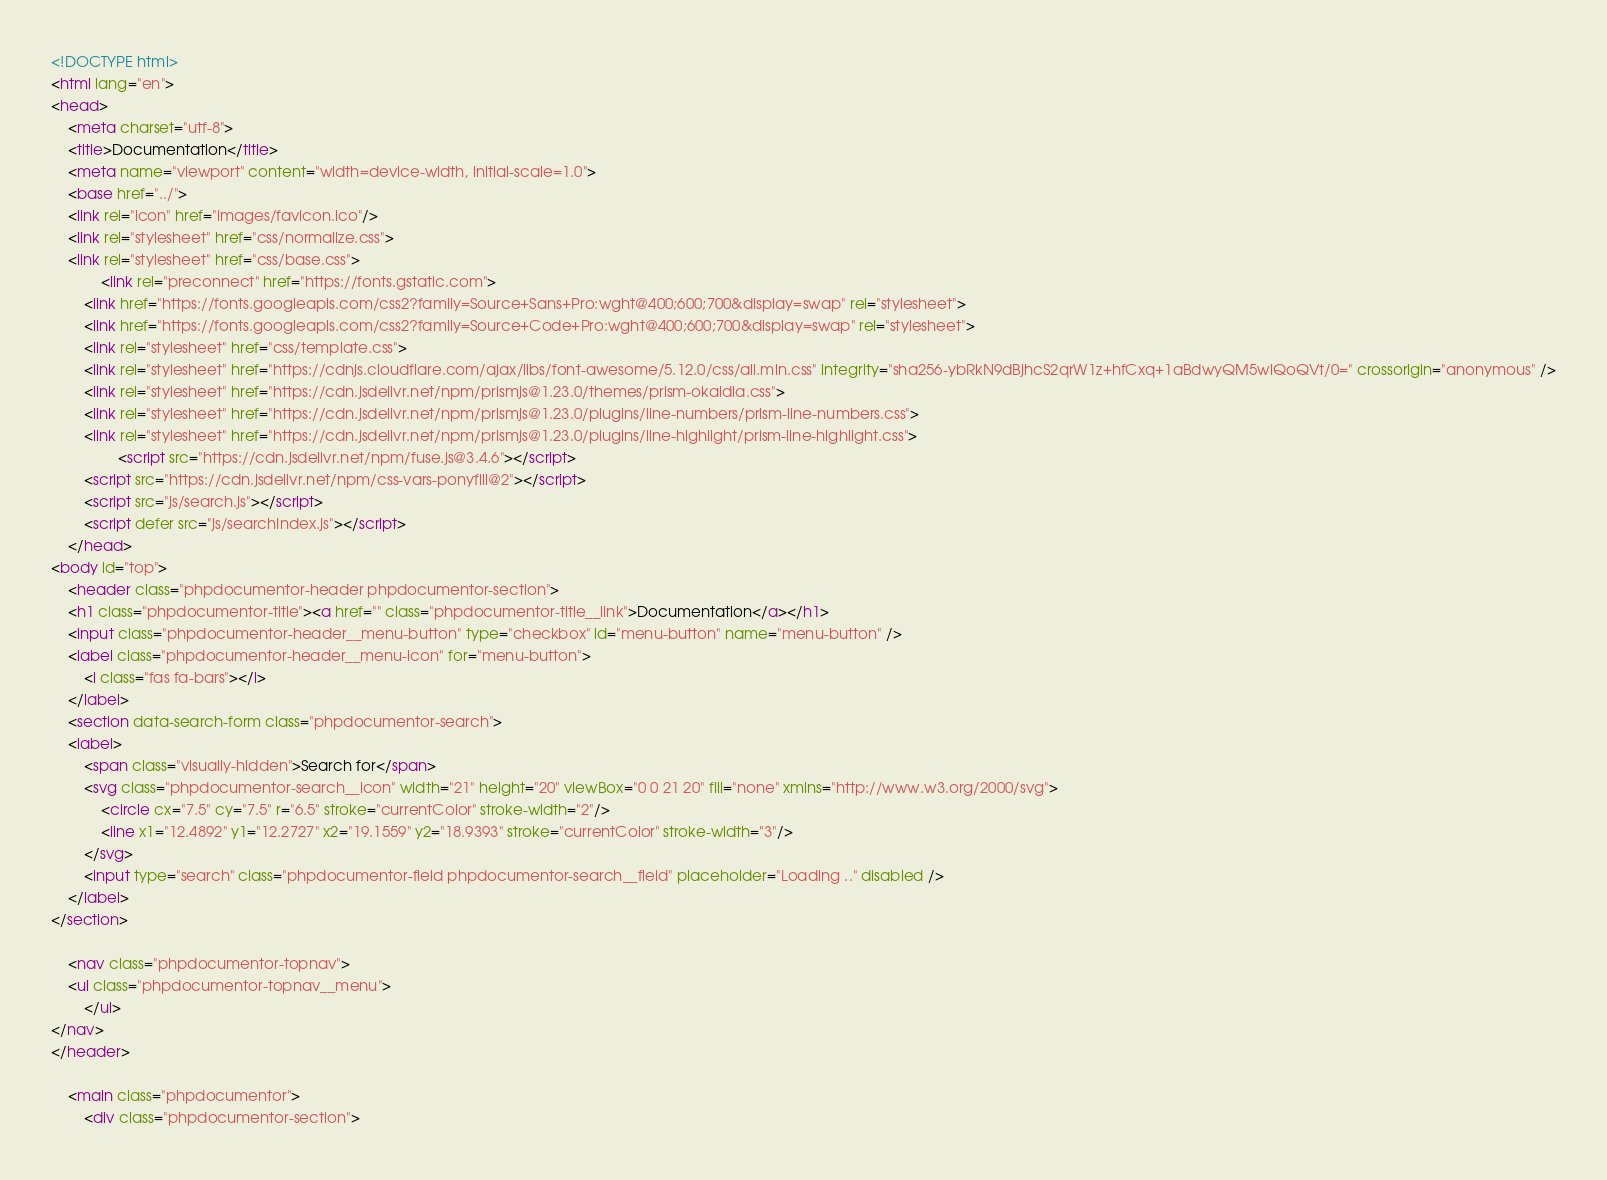<code> <loc_0><loc_0><loc_500><loc_500><_HTML_><!DOCTYPE html>
<html lang="en">
<head>
    <meta charset="utf-8">
    <title>Documentation</title>
    <meta name="viewport" content="width=device-width, initial-scale=1.0">
    <base href="../">
    <link rel="icon" href="images/favicon.ico"/>
    <link rel="stylesheet" href="css/normalize.css">
    <link rel="stylesheet" href="css/base.css">
            <link rel="preconnect" href="https://fonts.gstatic.com">
        <link href="https://fonts.googleapis.com/css2?family=Source+Sans+Pro:wght@400;600;700&display=swap" rel="stylesheet">
        <link href="https://fonts.googleapis.com/css2?family=Source+Code+Pro:wght@400;600;700&display=swap" rel="stylesheet">
        <link rel="stylesheet" href="css/template.css">
        <link rel="stylesheet" href="https://cdnjs.cloudflare.com/ajax/libs/font-awesome/5.12.0/css/all.min.css" integrity="sha256-ybRkN9dBjhcS2qrW1z+hfCxq+1aBdwyQM5wlQoQVt/0=" crossorigin="anonymous" />
        <link rel="stylesheet" href="https://cdn.jsdelivr.net/npm/prismjs@1.23.0/themes/prism-okaidia.css">
        <link rel="stylesheet" href="https://cdn.jsdelivr.net/npm/prismjs@1.23.0/plugins/line-numbers/prism-line-numbers.css">
        <link rel="stylesheet" href="https://cdn.jsdelivr.net/npm/prismjs@1.23.0/plugins/line-highlight/prism-line-highlight.css">
                <script src="https://cdn.jsdelivr.net/npm/fuse.js@3.4.6"></script>
        <script src="https://cdn.jsdelivr.net/npm/css-vars-ponyfill@2"></script>
        <script src="js/search.js"></script>
        <script defer src="js/searchIndex.js"></script>
    </head>
<body id="top">
    <header class="phpdocumentor-header phpdocumentor-section">
    <h1 class="phpdocumentor-title"><a href="" class="phpdocumentor-title__link">Documentation</a></h1>
    <input class="phpdocumentor-header__menu-button" type="checkbox" id="menu-button" name="menu-button" />
    <label class="phpdocumentor-header__menu-icon" for="menu-button">
        <i class="fas fa-bars"></i>
    </label>
    <section data-search-form class="phpdocumentor-search">
    <label>
        <span class="visually-hidden">Search for</span>
        <svg class="phpdocumentor-search__icon" width="21" height="20" viewBox="0 0 21 20" fill="none" xmlns="http://www.w3.org/2000/svg">
            <circle cx="7.5" cy="7.5" r="6.5" stroke="currentColor" stroke-width="2"/>
            <line x1="12.4892" y1="12.2727" x2="19.1559" y2="18.9393" stroke="currentColor" stroke-width="3"/>
        </svg>
        <input type="search" class="phpdocumentor-field phpdocumentor-search__field" placeholder="Loading .." disabled />
    </label>
</section>

    <nav class="phpdocumentor-topnav">
    <ul class="phpdocumentor-topnav__menu">
        </ul>
</nav>
</header>

    <main class="phpdocumentor">
        <div class="phpdocumentor-section"></code> 